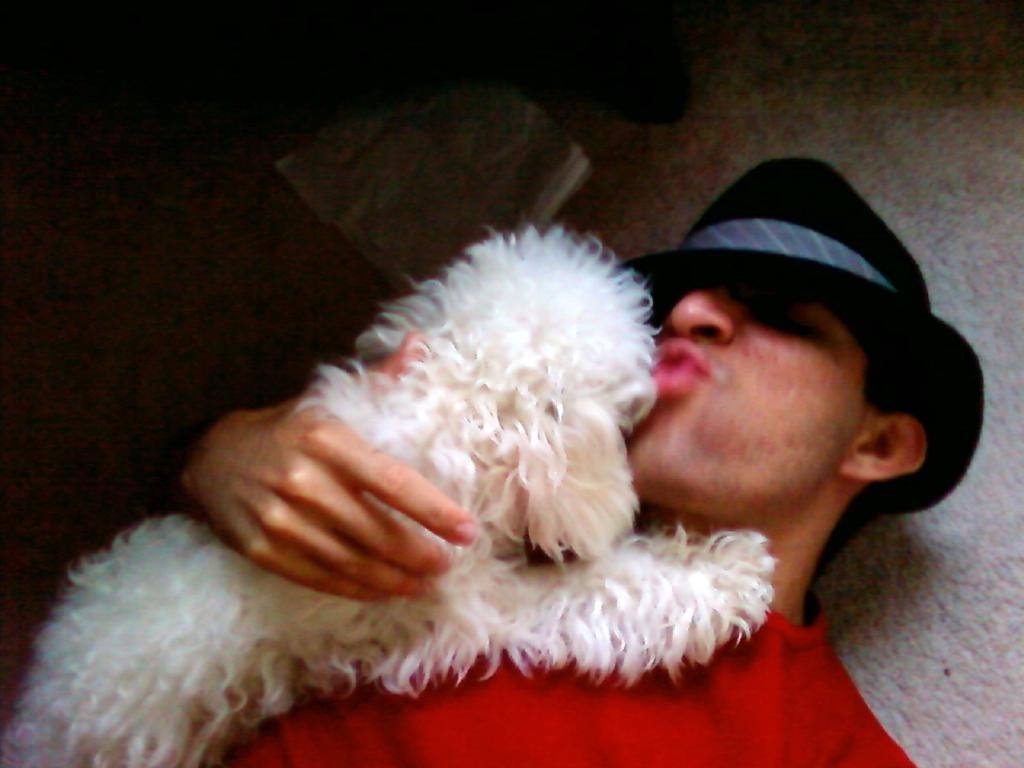What is the main subject of the image? There is a person in the image. What is the person doing in the image? The person is lying on the floor and holding a dog. What color is the shirt the person is wearing? The person is wearing a red shirt. What type of headwear is the person wearing? The person is wearing a cap. What type of caption is written on the person's shirt in the image? There is no caption written on the person's shirt in the image; it is simply a red shirt. Can you see a circle or ring in the image? There is no circle or ring present in the image. 